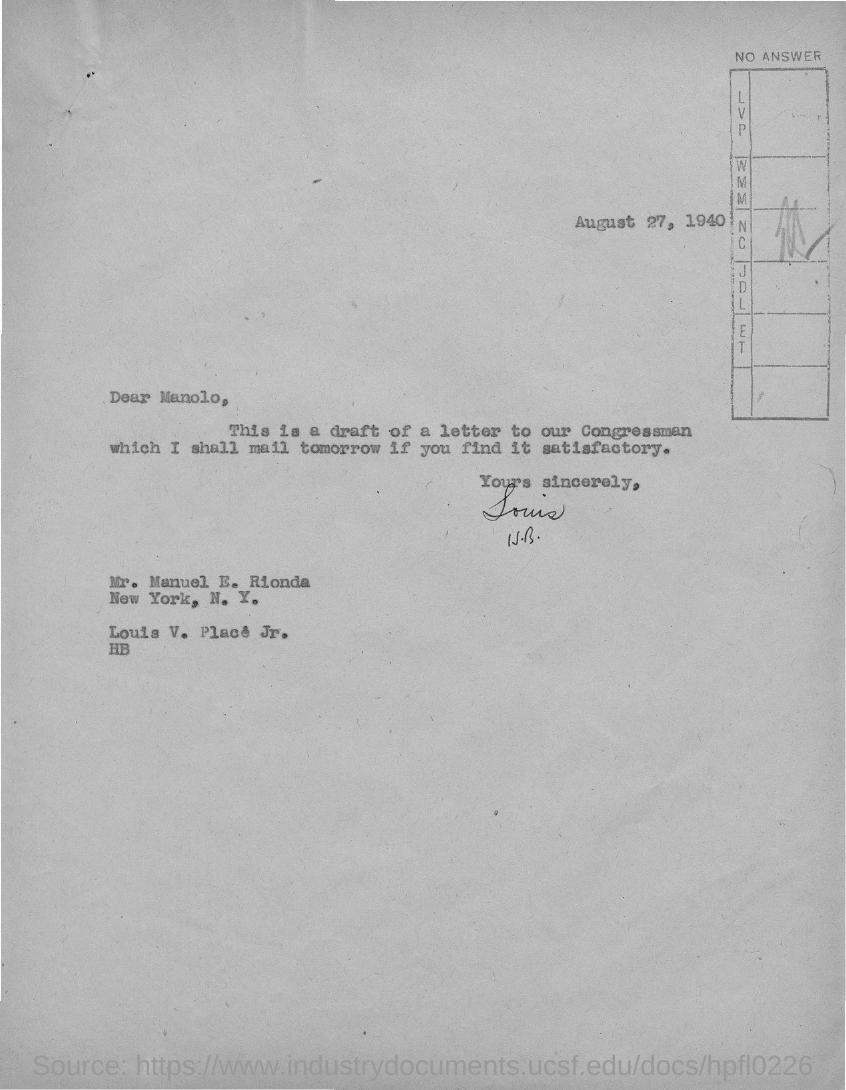What is the date on the document?
Your response must be concise. August 27, 1940. To Whom is this letter addressed to?
Provide a succinct answer. Manolo. Who is this letter from?
Provide a short and direct response. Louis V. Place Jr. This is a draft of which letter?
Offer a terse response. A letter to our Congressman. 